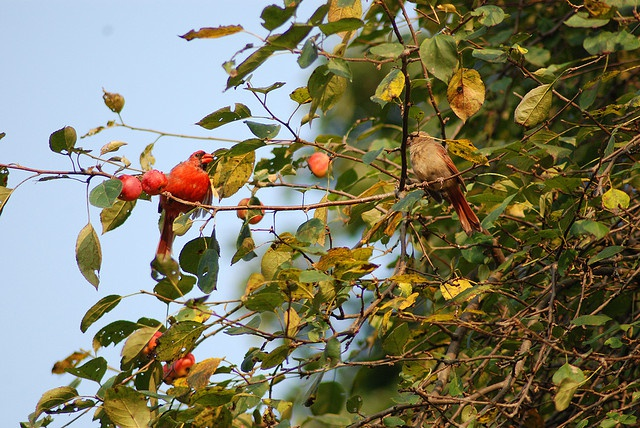Describe the objects in this image and their specific colors. I can see bird in lightblue, maroon, black, and red tones, bird in lightblue, tan, black, brown, and maroon tones, apple in lightblue, maroon, brown, black, and red tones, apple in lightblue, salmon, brown, red, and maroon tones, and apple in lightblue, salmon, red, maroon, and brown tones in this image. 